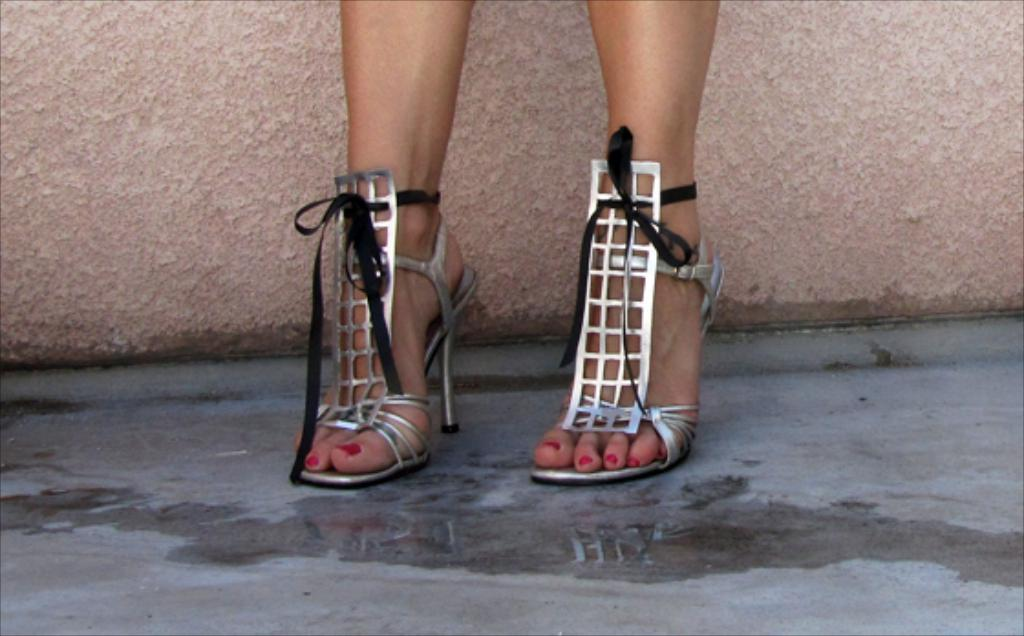What part of a person can be seen in the image? There are legs of a person visible in the image. What type of footwear is the person wearing? The person is wearing sandals. What is on the floor in the image? There is water on the floor in the image. What can be seen in the background of the image? There is a wall in the background of the image. What type of net is being used to catch the balloon in the image? There is no net or balloon present in the image. What is the person doing with the crate in the image? There is no crate present in the image. 